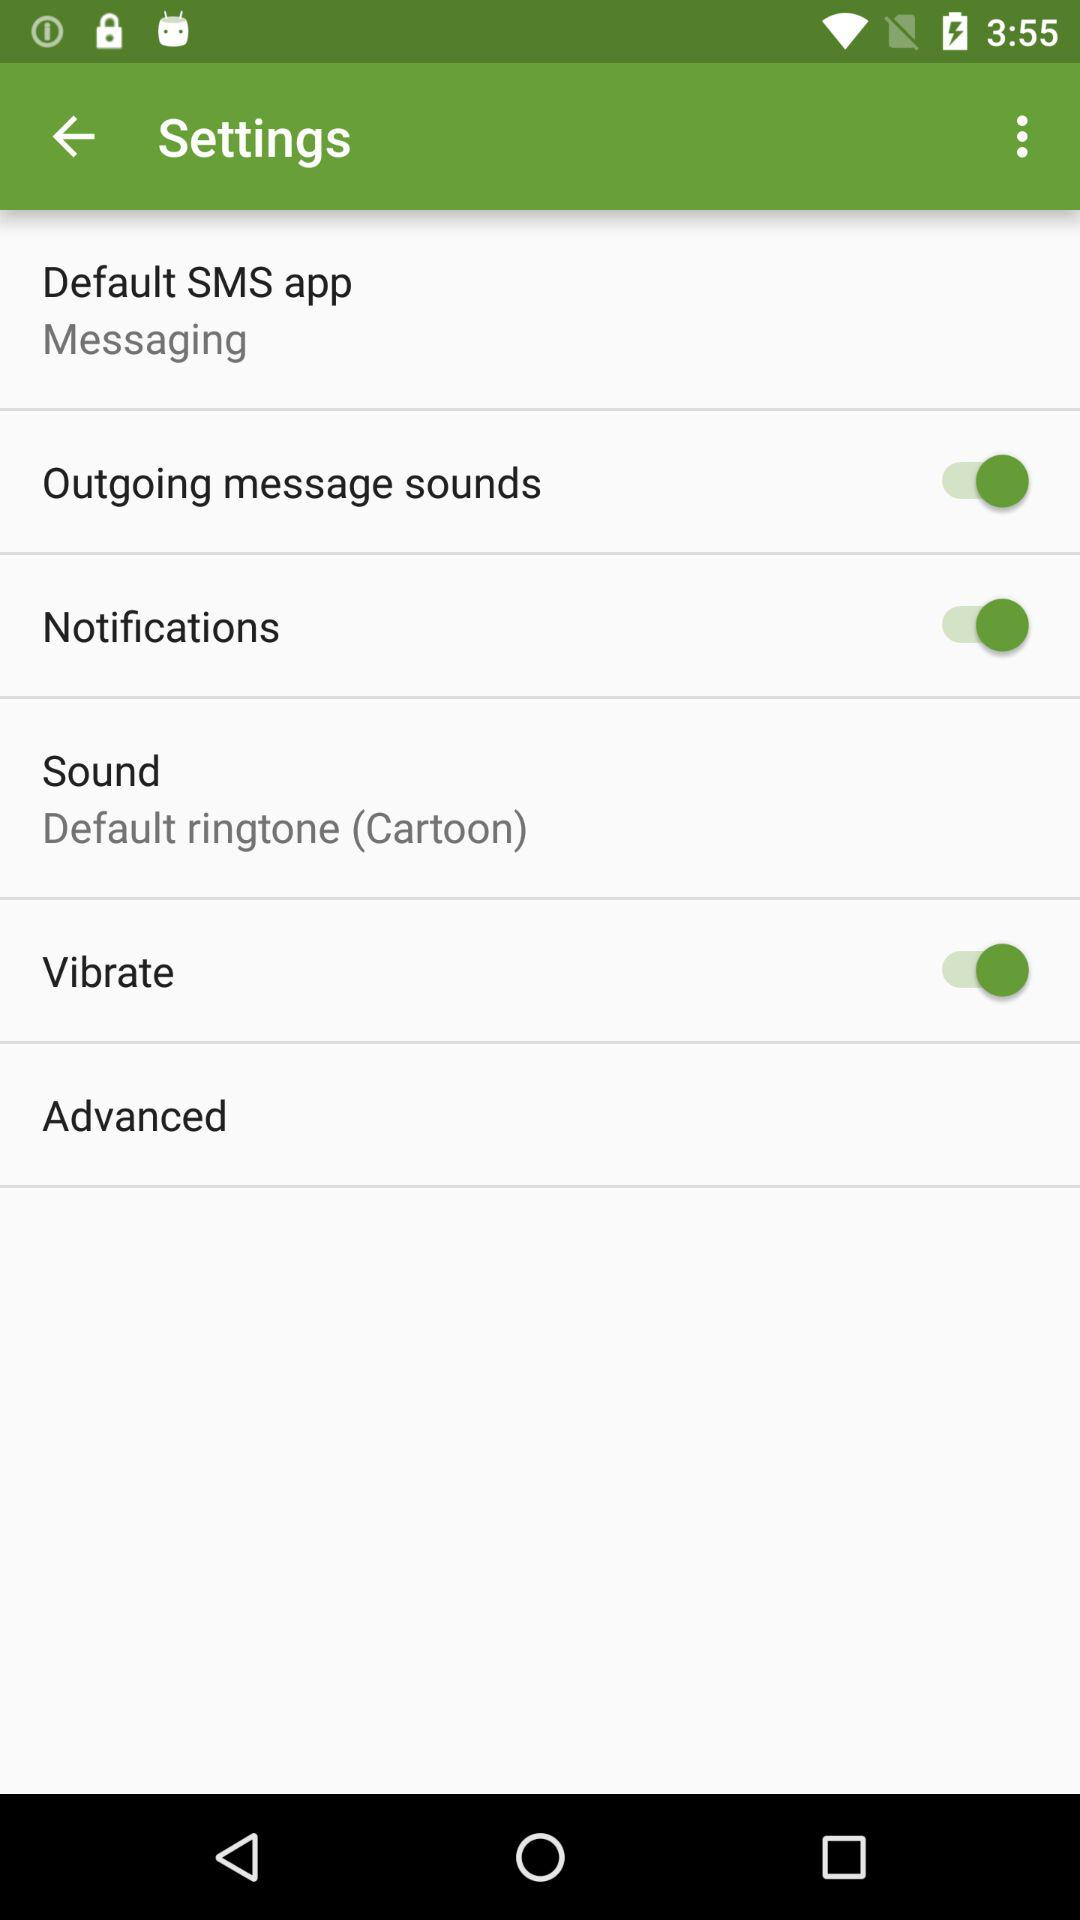What is the status of "Vibrate"? The status of "Vibrate" is "on". 